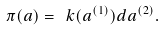Convert formula to latex. <formula><loc_0><loc_0><loc_500><loc_500>\pi ( a ) = \ k ( a ^ { ( 1 ) } ) d a ^ { ( 2 ) } .</formula> 